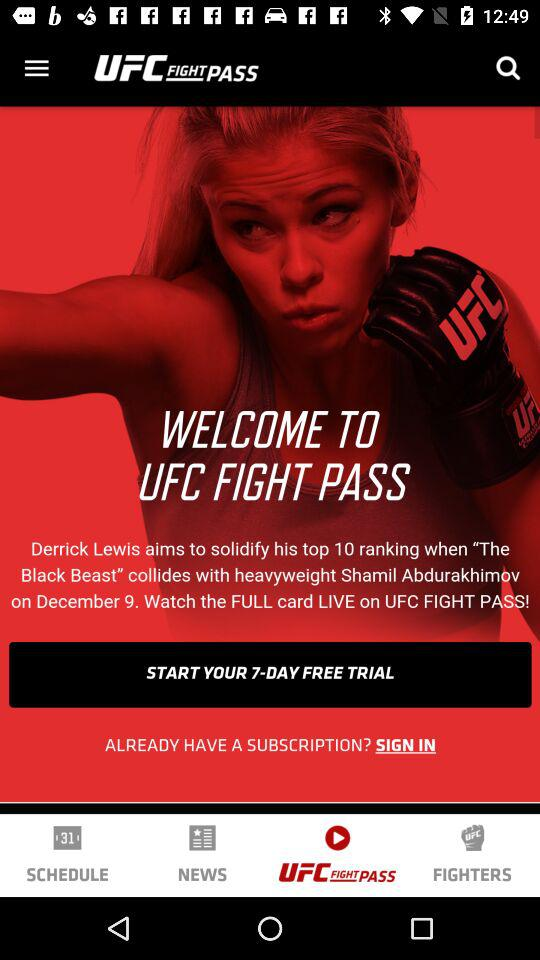How much of a free trial is there? There is a 7-day free trial. 